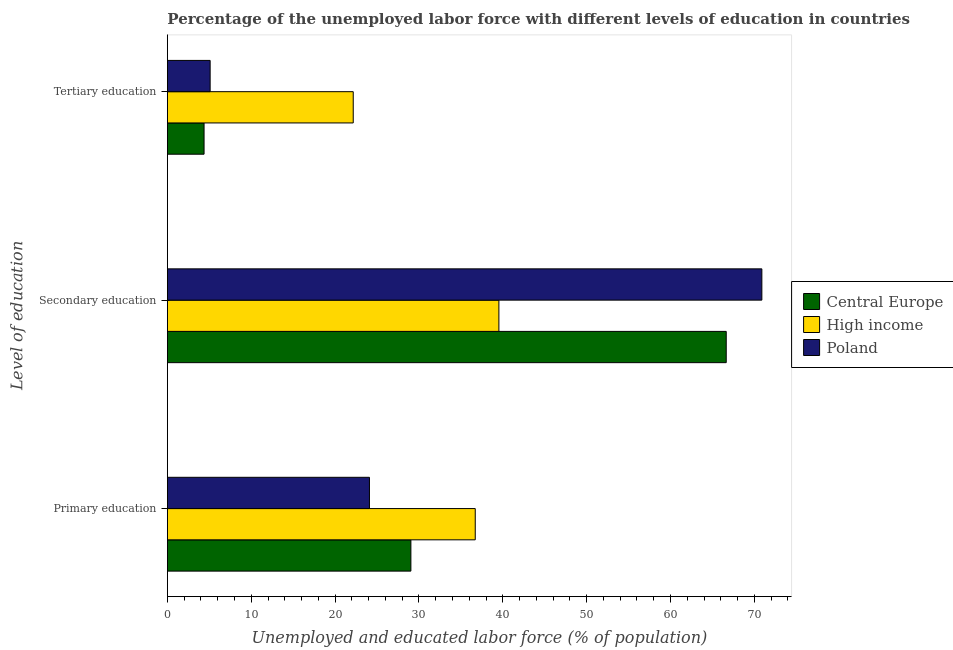What is the label of the 2nd group of bars from the top?
Your answer should be very brief. Secondary education. What is the percentage of labor force who received secondary education in High income?
Offer a terse response. 39.54. Across all countries, what is the maximum percentage of labor force who received tertiary education?
Provide a short and direct response. 22.17. Across all countries, what is the minimum percentage of labor force who received secondary education?
Give a very brief answer. 39.54. In which country was the percentage of labor force who received tertiary education maximum?
Give a very brief answer. High income. What is the total percentage of labor force who received tertiary education in the graph?
Your response must be concise. 31.64. What is the difference between the percentage of labor force who received secondary education in Central Europe and that in Poland?
Offer a very short reply. -4.25. What is the difference between the percentage of labor force who received secondary education in Poland and the percentage of labor force who received primary education in Central Europe?
Provide a succinct answer. 41.86. What is the average percentage of labor force who received primary education per country?
Your answer should be very brief. 29.95. What is the difference between the percentage of labor force who received secondary education and percentage of labor force who received primary education in High income?
Provide a short and direct response. 2.82. In how many countries, is the percentage of labor force who received tertiary education greater than 24 %?
Your answer should be compact. 0. What is the ratio of the percentage of labor force who received primary education in Central Europe to that in Poland?
Make the answer very short. 1.21. Is the difference between the percentage of labor force who received tertiary education in Poland and High income greater than the difference between the percentage of labor force who received primary education in Poland and High income?
Give a very brief answer. No. What is the difference between the highest and the second highest percentage of labor force who received secondary education?
Provide a succinct answer. 4.25. What is the difference between the highest and the lowest percentage of labor force who received tertiary education?
Your answer should be compact. 17.79. What does the 2nd bar from the bottom in Tertiary education represents?
Give a very brief answer. High income. Is it the case that in every country, the sum of the percentage of labor force who received primary education and percentage of labor force who received secondary education is greater than the percentage of labor force who received tertiary education?
Provide a succinct answer. Yes. How many bars are there?
Provide a succinct answer. 9. What is the difference between two consecutive major ticks on the X-axis?
Provide a short and direct response. 10. Are the values on the major ticks of X-axis written in scientific E-notation?
Provide a short and direct response. No. Does the graph contain grids?
Your answer should be very brief. No. Where does the legend appear in the graph?
Provide a short and direct response. Center right. How many legend labels are there?
Your answer should be very brief. 3. How are the legend labels stacked?
Provide a succinct answer. Vertical. What is the title of the graph?
Your answer should be very brief. Percentage of the unemployed labor force with different levels of education in countries. What is the label or title of the X-axis?
Offer a very short reply. Unemployed and educated labor force (% of population). What is the label or title of the Y-axis?
Make the answer very short. Level of education. What is the Unemployed and educated labor force (% of population) in Central Europe in Primary education?
Offer a terse response. 29.04. What is the Unemployed and educated labor force (% of population) of High income in Primary education?
Provide a succinct answer. 36.72. What is the Unemployed and educated labor force (% of population) of Poland in Primary education?
Ensure brevity in your answer.  24.1. What is the Unemployed and educated labor force (% of population) of Central Europe in Secondary education?
Make the answer very short. 66.65. What is the Unemployed and educated labor force (% of population) in High income in Secondary education?
Offer a very short reply. 39.54. What is the Unemployed and educated labor force (% of population) in Poland in Secondary education?
Keep it short and to the point. 70.9. What is the Unemployed and educated labor force (% of population) of Central Europe in Tertiary education?
Provide a succinct answer. 4.38. What is the Unemployed and educated labor force (% of population) of High income in Tertiary education?
Keep it short and to the point. 22.17. What is the Unemployed and educated labor force (% of population) in Poland in Tertiary education?
Offer a terse response. 5.1. Across all Level of education, what is the maximum Unemployed and educated labor force (% of population) of Central Europe?
Give a very brief answer. 66.65. Across all Level of education, what is the maximum Unemployed and educated labor force (% of population) in High income?
Provide a succinct answer. 39.54. Across all Level of education, what is the maximum Unemployed and educated labor force (% of population) of Poland?
Offer a very short reply. 70.9. Across all Level of education, what is the minimum Unemployed and educated labor force (% of population) in Central Europe?
Provide a succinct answer. 4.38. Across all Level of education, what is the minimum Unemployed and educated labor force (% of population) of High income?
Offer a very short reply. 22.17. Across all Level of education, what is the minimum Unemployed and educated labor force (% of population) of Poland?
Keep it short and to the point. 5.1. What is the total Unemployed and educated labor force (% of population) of Central Europe in the graph?
Provide a succinct answer. 100.07. What is the total Unemployed and educated labor force (% of population) of High income in the graph?
Give a very brief answer. 98.42. What is the total Unemployed and educated labor force (% of population) of Poland in the graph?
Ensure brevity in your answer.  100.1. What is the difference between the Unemployed and educated labor force (% of population) of Central Europe in Primary education and that in Secondary education?
Provide a short and direct response. -37.61. What is the difference between the Unemployed and educated labor force (% of population) of High income in Primary education and that in Secondary education?
Offer a terse response. -2.82. What is the difference between the Unemployed and educated labor force (% of population) of Poland in Primary education and that in Secondary education?
Your answer should be very brief. -46.8. What is the difference between the Unemployed and educated labor force (% of population) of Central Europe in Primary education and that in Tertiary education?
Keep it short and to the point. 24.67. What is the difference between the Unemployed and educated labor force (% of population) of High income in Primary education and that in Tertiary education?
Offer a very short reply. 14.55. What is the difference between the Unemployed and educated labor force (% of population) in Central Europe in Secondary education and that in Tertiary education?
Keep it short and to the point. 62.28. What is the difference between the Unemployed and educated labor force (% of population) of High income in Secondary education and that in Tertiary education?
Ensure brevity in your answer.  17.37. What is the difference between the Unemployed and educated labor force (% of population) of Poland in Secondary education and that in Tertiary education?
Provide a short and direct response. 65.8. What is the difference between the Unemployed and educated labor force (% of population) in Central Europe in Primary education and the Unemployed and educated labor force (% of population) in High income in Secondary education?
Give a very brief answer. -10.49. What is the difference between the Unemployed and educated labor force (% of population) of Central Europe in Primary education and the Unemployed and educated labor force (% of population) of Poland in Secondary education?
Your response must be concise. -41.86. What is the difference between the Unemployed and educated labor force (% of population) of High income in Primary education and the Unemployed and educated labor force (% of population) of Poland in Secondary education?
Provide a succinct answer. -34.18. What is the difference between the Unemployed and educated labor force (% of population) of Central Europe in Primary education and the Unemployed and educated labor force (% of population) of High income in Tertiary education?
Make the answer very short. 6.88. What is the difference between the Unemployed and educated labor force (% of population) in Central Europe in Primary education and the Unemployed and educated labor force (% of population) in Poland in Tertiary education?
Offer a very short reply. 23.94. What is the difference between the Unemployed and educated labor force (% of population) in High income in Primary education and the Unemployed and educated labor force (% of population) in Poland in Tertiary education?
Ensure brevity in your answer.  31.62. What is the difference between the Unemployed and educated labor force (% of population) in Central Europe in Secondary education and the Unemployed and educated labor force (% of population) in High income in Tertiary education?
Provide a short and direct response. 44.48. What is the difference between the Unemployed and educated labor force (% of population) in Central Europe in Secondary education and the Unemployed and educated labor force (% of population) in Poland in Tertiary education?
Your answer should be compact. 61.55. What is the difference between the Unemployed and educated labor force (% of population) of High income in Secondary education and the Unemployed and educated labor force (% of population) of Poland in Tertiary education?
Your response must be concise. 34.44. What is the average Unemployed and educated labor force (% of population) in Central Europe per Level of education?
Your answer should be compact. 33.36. What is the average Unemployed and educated labor force (% of population) in High income per Level of education?
Make the answer very short. 32.81. What is the average Unemployed and educated labor force (% of population) in Poland per Level of education?
Offer a terse response. 33.37. What is the difference between the Unemployed and educated labor force (% of population) of Central Europe and Unemployed and educated labor force (% of population) of High income in Primary education?
Make the answer very short. -7.67. What is the difference between the Unemployed and educated labor force (% of population) in Central Europe and Unemployed and educated labor force (% of population) in Poland in Primary education?
Provide a succinct answer. 4.94. What is the difference between the Unemployed and educated labor force (% of population) in High income and Unemployed and educated labor force (% of population) in Poland in Primary education?
Ensure brevity in your answer.  12.62. What is the difference between the Unemployed and educated labor force (% of population) of Central Europe and Unemployed and educated labor force (% of population) of High income in Secondary education?
Offer a very short reply. 27.11. What is the difference between the Unemployed and educated labor force (% of population) of Central Europe and Unemployed and educated labor force (% of population) of Poland in Secondary education?
Offer a very short reply. -4.25. What is the difference between the Unemployed and educated labor force (% of population) in High income and Unemployed and educated labor force (% of population) in Poland in Secondary education?
Provide a succinct answer. -31.36. What is the difference between the Unemployed and educated labor force (% of population) of Central Europe and Unemployed and educated labor force (% of population) of High income in Tertiary education?
Offer a terse response. -17.79. What is the difference between the Unemployed and educated labor force (% of population) of Central Europe and Unemployed and educated labor force (% of population) of Poland in Tertiary education?
Provide a short and direct response. -0.72. What is the difference between the Unemployed and educated labor force (% of population) in High income and Unemployed and educated labor force (% of population) in Poland in Tertiary education?
Offer a very short reply. 17.07. What is the ratio of the Unemployed and educated labor force (% of population) of Central Europe in Primary education to that in Secondary education?
Provide a succinct answer. 0.44. What is the ratio of the Unemployed and educated labor force (% of population) in High income in Primary education to that in Secondary education?
Keep it short and to the point. 0.93. What is the ratio of the Unemployed and educated labor force (% of population) of Poland in Primary education to that in Secondary education?
Keep it short and to the point. 0.34. What is the ratio of the Unemployed and educated labor force (% of population) of Central Europe in Primary education to that in Tertiary education?
Keep it short and to the point. 6.64. What is the ratio of the Unemployed and educated labor force (% of population) of High income in Primary education to that in Tertiary education?
Make the answer very short. 1.66. What is the ratio of the Unemployed and educated labor force (% of population) of Poland in Primary education to that in Tertiary education?
Provide a succinct answer. 4.73. What is the ratio of the Unemployed and educated labor force (% of population) of Central Europe in Secondary education to that in Tertiary education?
Make the answer very short. 15.23. What is the ratio of the Unemployed and educated labor force (% of population) of High income in Secondary education to that in Tertiary education?
Your answer should be very brief. 1.78. What is the ratio of the Unemployed and educated labor force (% of population) in Poland in Secondary education to that in Tertiary education?
Offer a terse response. 13.9. What is the difference between the highest and the second highest Unemployed and educated labor force (% of population) in Central Europe?
Give a very brief answer. 37.61. What is the difference between the highest and the second highest Unemployed and educated labor force (% of population) of High income?
Offer a very short reply. 2.82. What is the difference between the highest and the second highest Unemployed and educated labor force (% of population) of Poland?
Make the answer very short. 46.8. What is the difference between the highest and the lowest Unemployed and educated labor force (% of population) in Central Europe?
Your response must be concise. 62.28. What is the difference between the highest and the lowest Unemployed and educated labor force (% of population) of High income?
Keep it short and to the point. 17.37. What is the difference between the highest and the lowest Unemployed and educated labor force (% of population) of Poland?
Offer a very short reply. 65.8. 